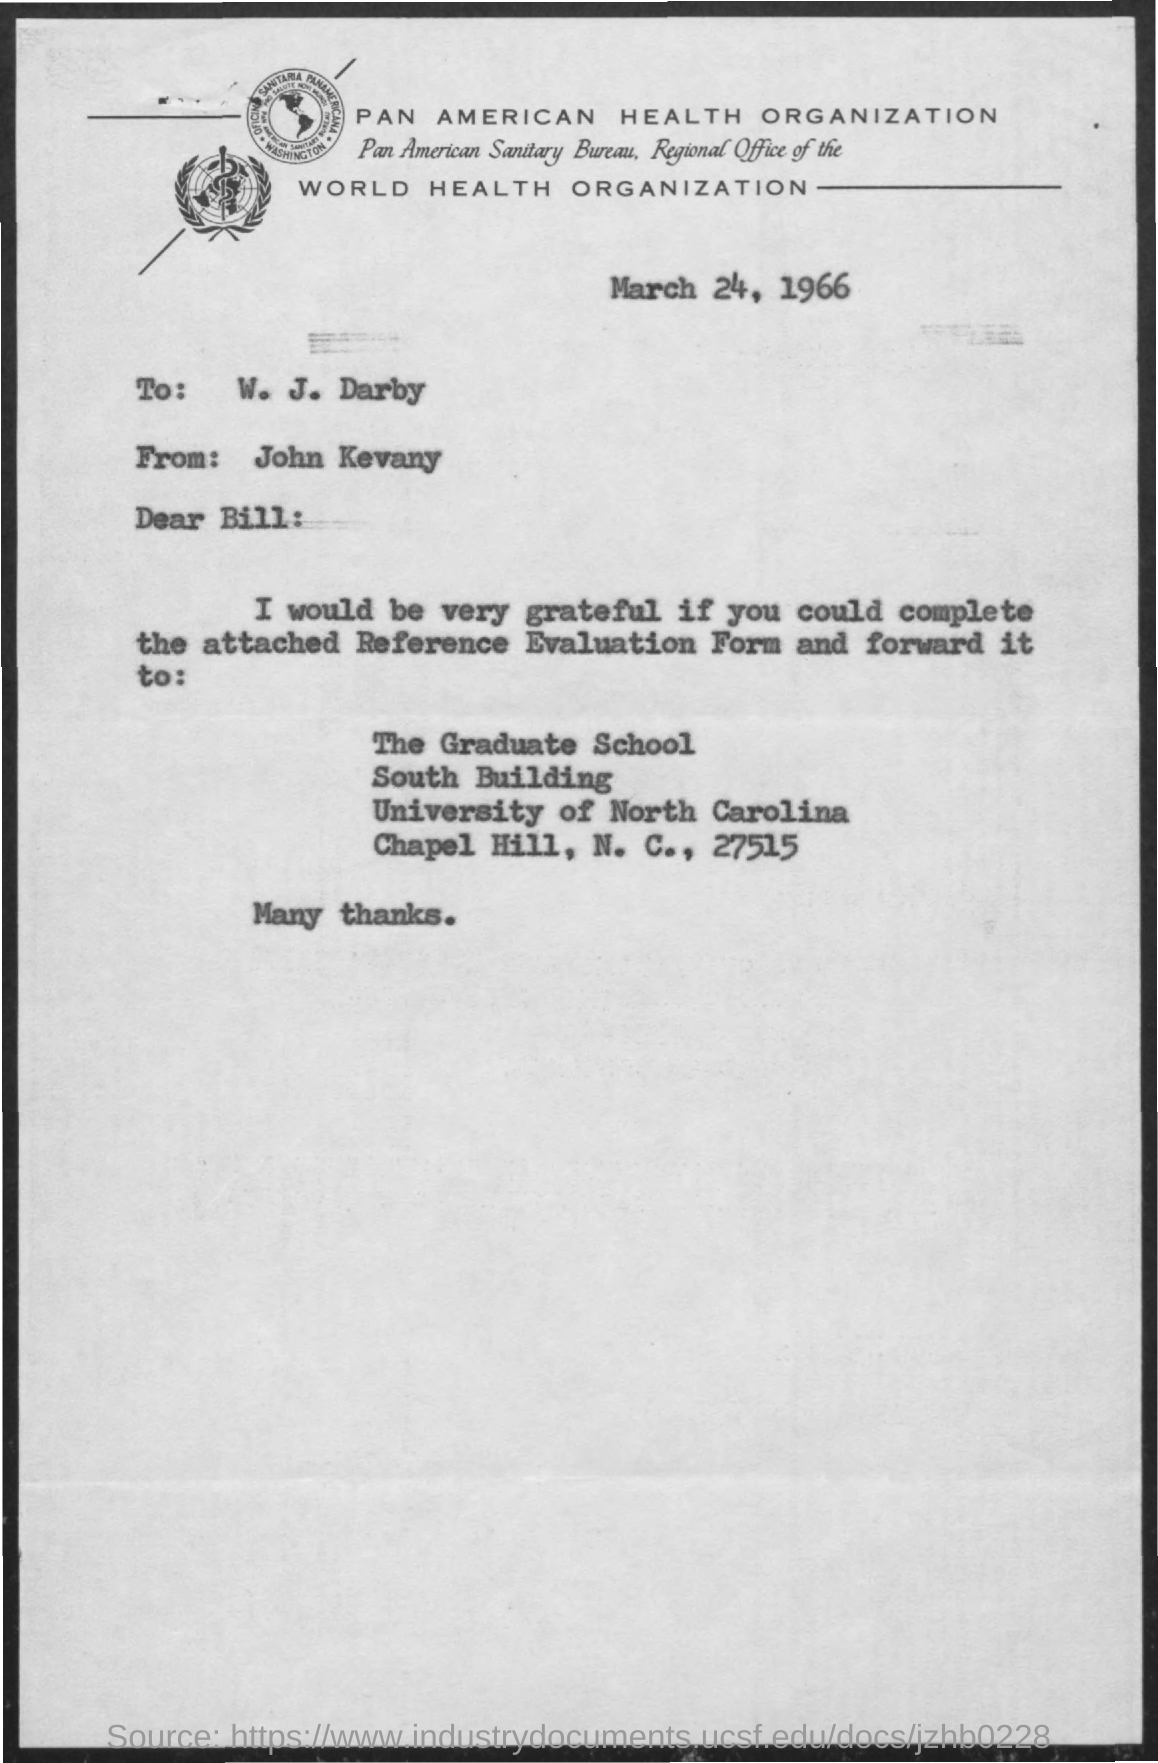List a handful of essential elements in this visual. The document is dated March 24, 1966. It is necessary to fill and forward the Reference Evaluation Form. The letter is addressed to Bill. The letter is from John Kevany. 